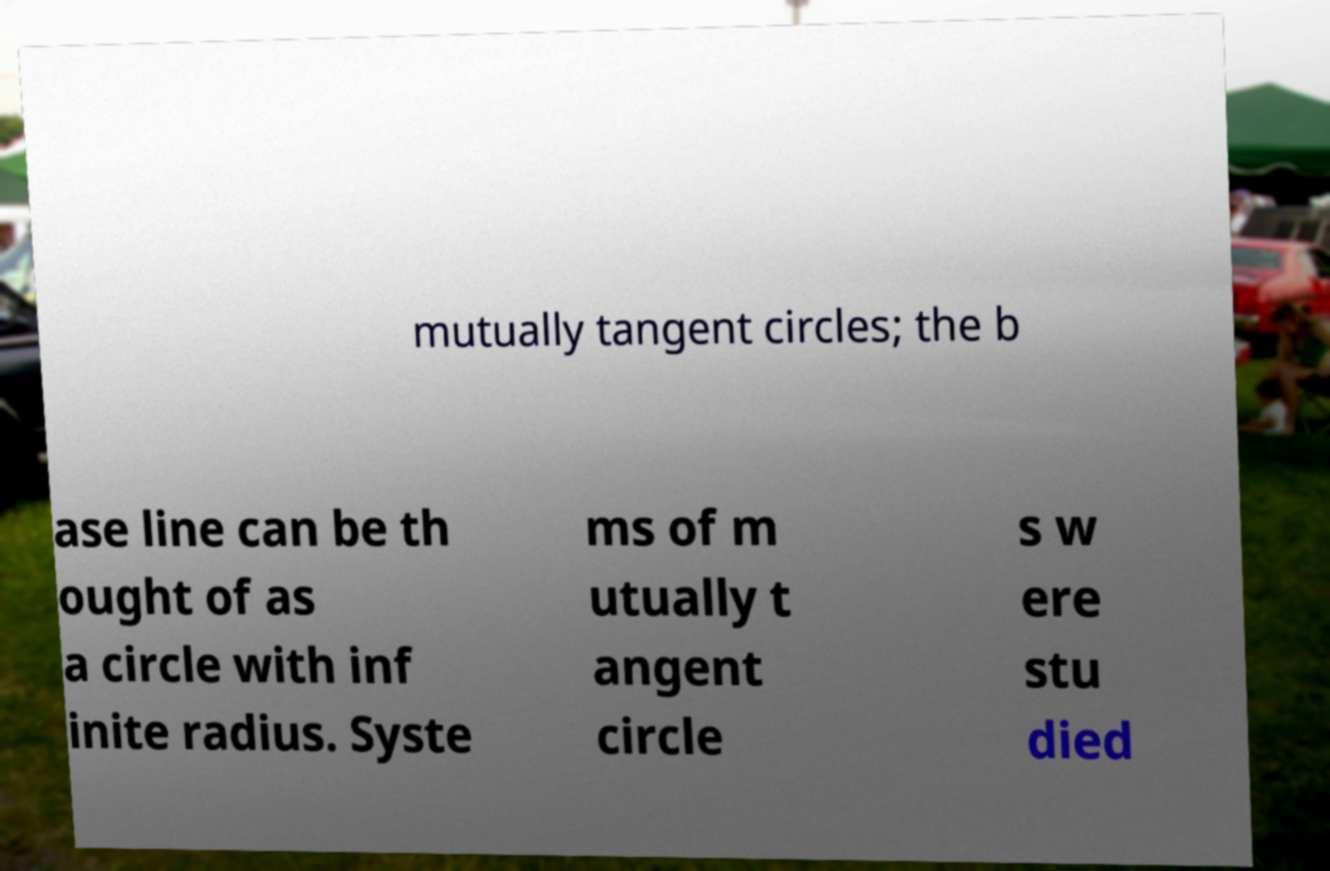Can you accurately transcribe the text from the provided image for me? mutually tangent circles; the b ase line can be th ought of as a circle with inf inite radius. Syste ms of m utually t angent circle s w ere stu died 